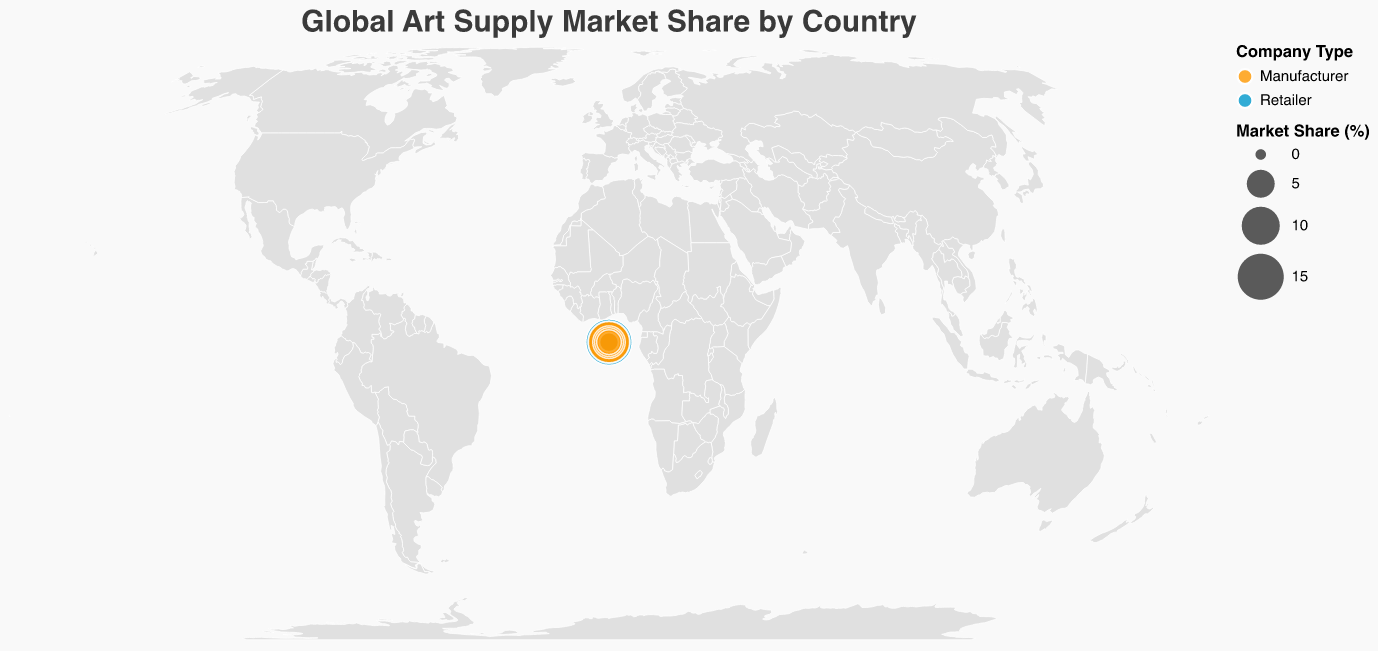What is the title of the figure? The title of the figure is usually placed at the top and describes the content or main message of the plot. In this case, the title states "Global Art Supply Market Share by Country."
Answer: Global Art Supply Market Share by Country How many companies are shown in the figure? By counting the number of unique company entries in the data given, we can determine the total number of companies represented on the plot.
Answer: 15 Which country has the highest market share? By examining the data points on the map, we find that the United States, shown as a large circle, has the highest market share of 15.2%.
Answer: United States Compare the market shares of Japan and France. Which one is higher and by how much? Japan has a market share of 6.3%, while France has a market share of 5.8%. Subtracting the two gives 0.5%.
Answer: Japan by 0.5% What is the total market share of all manufacturers? The manufacturers' market shares are summed up: (8.7 (China) + 12.5 (Germany) + 6.3 (Japan) + 5.8 (France) + 11.9 (United Kingdom) + 4.2 (Italy) + 7.1 (Netherlands) + 3.9 (Spain) + 5.4 (Switzerland) + 1.8 (Brazil) + 3.7 (South Korea)) = 71.3%.
Answer: 71.3% Which company type, retailer or manufacturer, has a higher presence globally? By counting the number of data points classified by type, there are 5 retailers and 10 manufacturers. Thus, manufacturers have a higher global presence.
Answer: Manufacturer What is the average market share of the retailers? Sum the market shares of retailers and divide by the number of retailers: (15.2 + 3.6 + 2.8 + 2.1) / 5 = 4.54%.
Answer: 4.54% Which country in Europe has the smallest market share? Among the European countries listed (Germany, France, United Kingdom, Italy, Netherlands, Spain, Switzerland), Spain has the smallest market share at 3.9%.
Answer: Spain What is the market share difference between the largest retailer and the largest manufacturer? The largest retailer, Blick Art Materials (United States), has a market share of 15.2%, while the largest manufacturer, Faber-Castell (Germany), has a market share of 12.5%. The difference is 15.2 - 12.5 = 2.7%.
Answer: 2.7% 